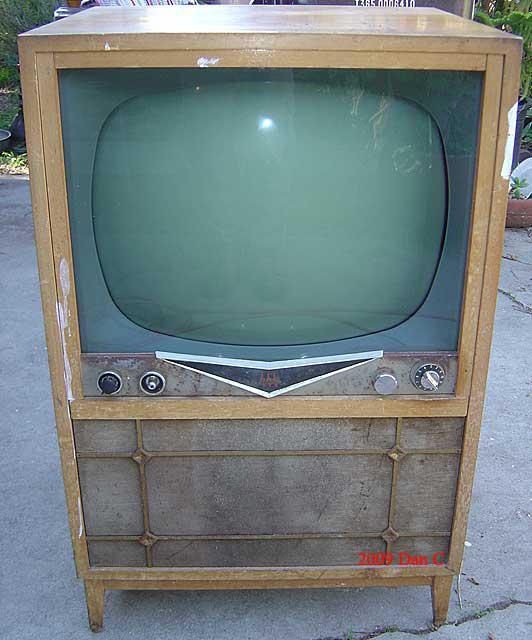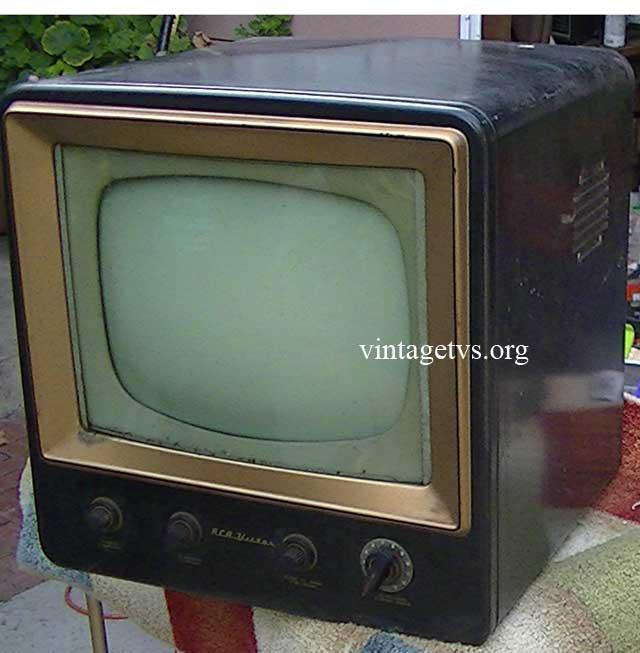The first image is the image on the left, the second image is the image on the right. Given the left and right images, does the statement "One of the televisions has an underneath speaker." hold true? Answer yes or no. Yes. The first image is the image on the left, the second image is the image on the right. Examine the images to the left and right. Is the description "The TV on the left is sitting on a wood surface, and the TV on the right is a console style with its screen in a wooden case with no panel under the screen and with slender legs." accurate? Answer yes or no. No. 